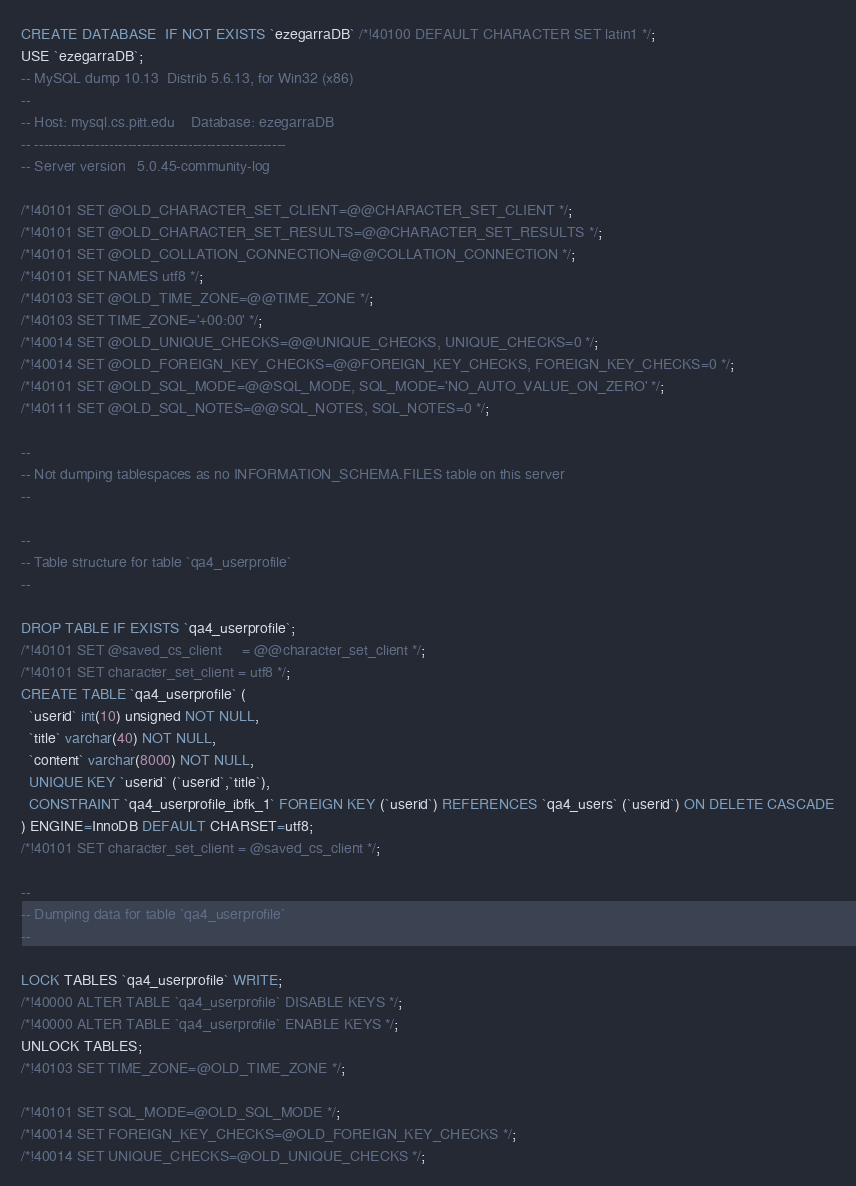<code> <loc_0><loc_0><loc_500><loc_500><_SQL_>CREATE DATABASE  IF NOT EXISTS `ezegarraDB` /*!40100 DEFAULT CHARACTER SET latin1 */;
USE `ezegarraDB`;
-- MySQL dump 10.13  Distrib 5.6.13, for Win32 (x86)
--
-- Host: mysql.cs.pitt.edu    Database: ezegarraDB
-- ------------------------------------------------------
-- Server version	5.0.45-community-log

/*!40101 SET @OLD_CHARACTER_SET_CLIENT=@@CHARACTER_SET_CLIENT */;
/*!40101 SET @OLD_CHARACTER_SET_RESULTS=@@CHARACTER_SET_RESULTS */;
/*!40101 SET @OLD_COLLATION_CONNECTION=@@COLLATION_CONNECTION */;
/*!40101 SET NAMES utf8 */;
/*!40103 SET @OLD_TIME_ZONE=@@TIME_ZONE */;
/*!40103 SET TIME_ZONE='+00:00' */;
/*!40014 SET @OLD_UNIQUE_CHECKS=@@UNIQUE_CHECKS, UNIQUE_CHECKS=0 */;
/*!40014 SET @OLD_FOREIGN_KEY_CHECKS=@@FOREIGN_KEY_CHECKS, FOREIGN_KEY_CHECKS=0 */;
/*!40101 SET @OLD_SQL_MODE=@@SQL_MODE, SQL_MODE='NO_AUTO_VALUE_ON_ZERO' */;
/*!40111 SET @OLD_SQL_NOTES=@@SQL_NOTES, SQL_NOTES=0 */;

--
-- Not dumping tablespaces as no INFORMATION_SCHEMA.FILES table on this server
--

--
-- Table structure for table `qa4_userprofile`
--

DROP TABLE IF EXISTS `qa4_userprofile`;
/*!40101 SET @saved_cs_client     = @@character_set_client */;
/*!40101 SET character_set_client = utf8 */;
CREATE TABLE `qa4_userprofile` (
  `userid` int(10) unsigned NOT NULL,
  `title` varchar(40) NOT NULL,
  `content` varchar(8000) NOT NULL,
  UNIQUE KEY `userid` (`userid`,`title`),
  CONSTRAINT `qa4_userprofile_ibfk_1` FOREIGN KEY (`userid`) REFERENCES `qa4_users` (`userid`) ON DELETE CASCADE
) ENGINE=InnoDB DEFAULT CHARSET=utf8;
/*!40101 SET character_set_client = @saved_cs_client */;

--
-- Dumping data for table `qa4_userprofile`
--

LOCK TABLES `qa4_userprofile` WRITE;
/*!40000 ALTER TABLE `qa4_userprofile` DISABLE KEYS */;
/*!40000 ALTER TABLE `qa4_userprofile` ENABLE KEYS */;
UNLOCK TABLES;
/*!40103 SET TIME_ZONE=@OLD_TIME_ZONE */;

/*!40101 SET SQL_MODE=@OLD_SQL_MODE */;
/*!40014 SET FOREIGN_KEY_CHECKS=@OLD_FOREIGN_KEY_CHECKS */;
/*!40014 SET UNIQUE_CHECKS=@OLD_UNIQUE_CHECKS */;</code> 